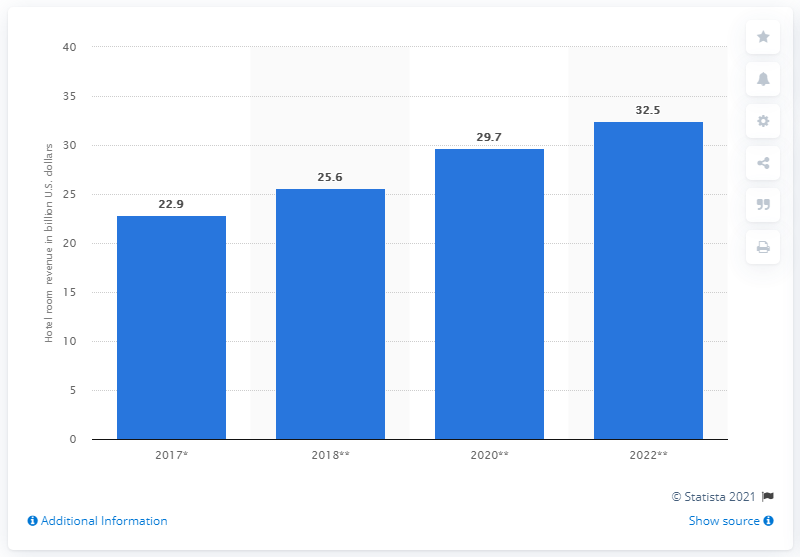Mention a couple of crucial points in this snapshot. According to estimates, the total revenue generated from hotel rooms in GCC countries in 2022 was approximately 32.5 million. 